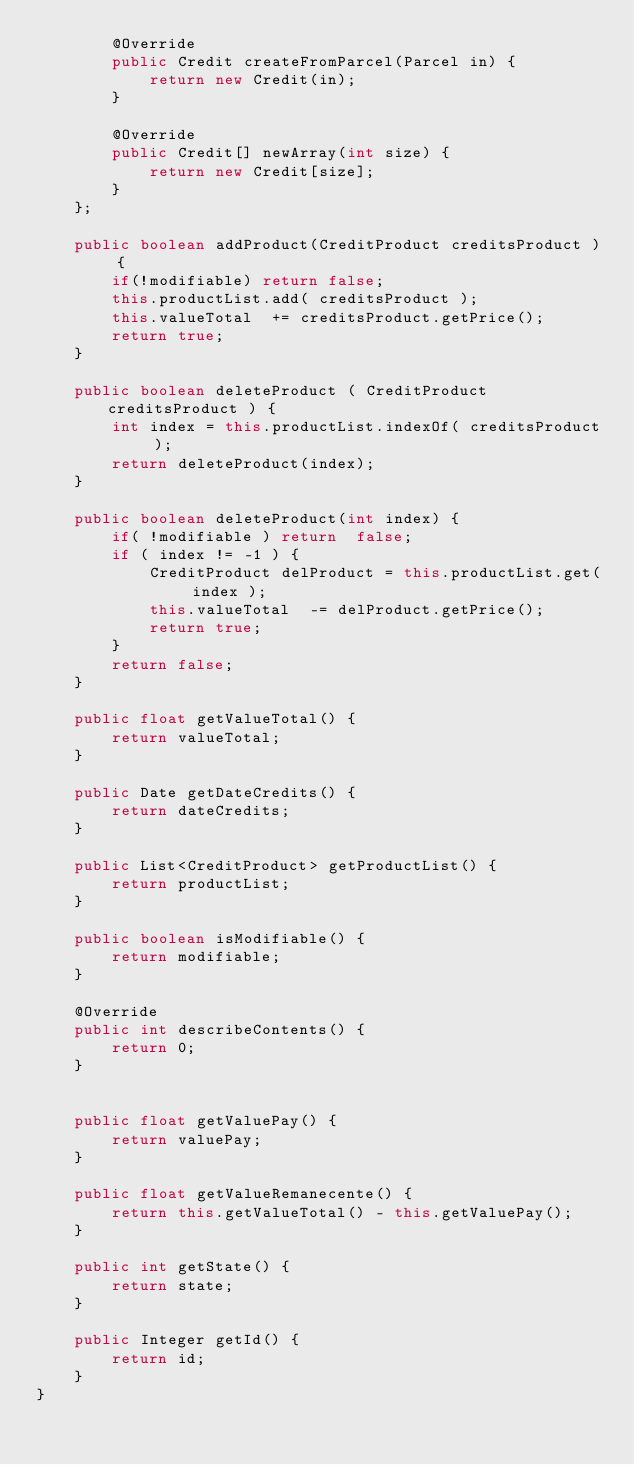<code> <loc_0><loc_0><loc_500><loc_500><_Java_>        @Override
        public Credit createFromParcel(Parcel in) {
            return new Credit(in);
        }

        @Override
        public Credit[] newArray(int size) {
            return new Credit[size];
        }
    };

    public boolean addProduct(CreditProduct creditsProduct ) {
        if(!modifiable) return false;
        this.productList.add( creditsProduct );
        this.valueTotal  += creditsProduct.getPrice();
        return true;
    }

    public boolean deleteProduct ( CreditProduct creditsProduct ) {
        int index = this.productList.indexOf( creditsProduct );
        return deleteProduct(index);
    }

    public boolean deleteProduct(int index) {
        if( !modifiable ) return  false;
        if ( index != -1 ) {
            CreditProduct delProduct = this.productList.get( index );
            this.valueTotal  -= delProduct.getPrice();
            return true;
        }
        return false;
    }

    public float getValueTotal() {
        return valueTotal;
    }

    public Date getDateCredits() {
        return dateCredits;
    }

    public List<CreditProduct> getProductList() {
        return productList;
    }

    public boolean isModifiable() {
        return modifiable;
    }

    @Override
    public int describeContents() {
        return 0;
    }


    public float getValuePay() {
        return valuePay;
    }

    public float getValueRemanecente() {
        return this.getValueTotal() - this.getValuePay();
    }

    public int getState() {
        return state;
    }

    public Integer getId() {
        return id;
    }
}
</code> 